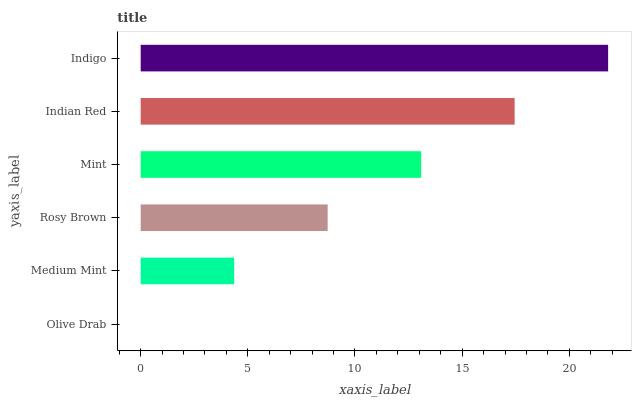Is Olive Drab the minimum?
Answer yes or no. Yes. Is Indigo the maximum?
Answer yes or no. Yes. Is Medium Mint the minimum?
Answer yes or no. No. Is Medium Mint the maximum?
Answer yes or no. No. Is Medium Mint greater than Olive Drab?
Answer yes or no. Yes. Is Olive Drab less than Medium Mint?
Answer yes or no. Yes. Is Olive Drab greater than Medium Mint?
Answer yes or no. No. Is Medium Mint less than Olive Drab?
Answer yes or no. No. Is Mint the high median?
Answer yes or no. Yes. Is Rosy Brown the low median?
Answer yes or no. Yes. Is Indigo the high median?
Answer yes or no. No. Is Olive Drab the low median?
Answer yes or no. No. 